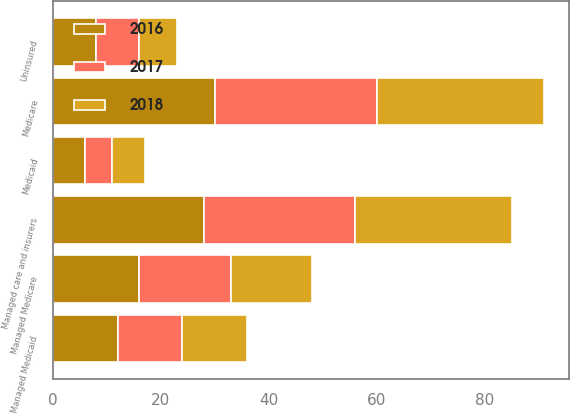<chart> <loc_0><loc_0><loc_500><loc_500><stacked_bar_chart><ecel><fcel>Medicare<fcel>Managed Medicare<fcel>Medicaid<fcel>Managed Medicaid<fcel>Managed care and insurers<fcel>Uninsured<nl><fcel>2017<fcel>30<fcel>17<fcel>5<fcel>12<fcel>28<fcel>8<nl><fcel>2016<fcel>30<fcel>16<fcel>6<fcel>12<fcel>28<fcel>8<nl><fcel>2018<fcel>31<fcel>15<fcel>6<fcel>12<fcel>29<fcel>7<nl></chart> 